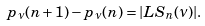<formula> <loc_0><loc_0><loc_500><loc_500>p _ { \nu } ( n + 1 ) - p _ { \nu } ( n ) = | L S _ { n } ( \nu ) | .</formula> 